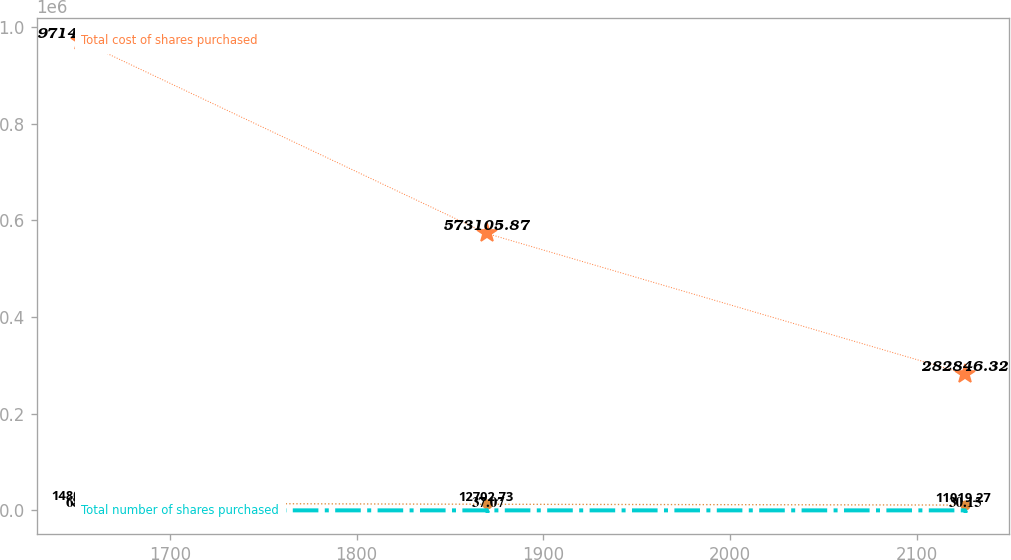Convert chart. <chart><loc_0><loc_0><loc_500><loc_500><line_chart><ecel><fcel>Total cost of shares purchased<fcel>Average price paid per share<fcel>Total number of shares purchased<nl><fcel>1652.32<fcel>971404<fcel>14800<fcel>68.88<nl><fcel>1869.71<fcel>573106<fcel>12702.7<fcel>37.07<nl><fcel>2125.59<fcel>282846<fcel>11019.3<fcel>30.15<nl></chart> 